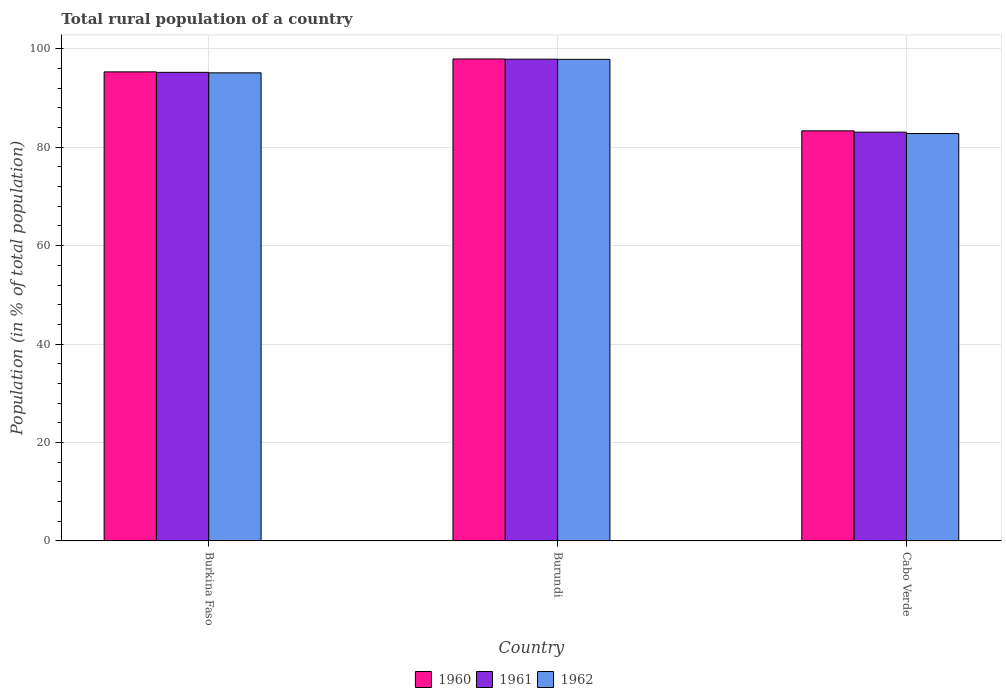How many bars are there on the 1st tick from the right?
Offer a very short reply. 3. What is the label of the 3rd group of bars from the left?
Offer a very short reply. Cabo Verde. In how many cases, is the number of bars for a given country not equal to the number of legend labels?
Provide a succinct answer. 0. What is the rural population in 1960 in Cabo Verde?
Your answer should be very brief. 83.32. Across all countries, what is the maximum rural population in 1960?
Your answer should be very brief. 97.92. Across all countries, what is the minimum rural population in 1962?
Give a very brief answer. 82.78. In which country was the rural population in 1961 maximum?
Your response must be concise. Burundi. In which country was the rural population in 1960 minimum?
Keep it short and to the point. Cabo Verde. What is the total rural population in 1962 in the graph?
Provide a succinct answer. 275.73. What is the difference between the rural population in 1960 in Burkina Faso and that in Burundi?
Your answer should be compact. -2.62. What is the difference between the rural population in 1960 in Cabo Verde and the rural population in 1961 in Burundi?
Give a very brief answer. -14.56. What is the average rural population in 1962 per country?
Offer a terse response. 91.91. What is the difference between the rural population of/in 1960 and rural population of/in 1961 in Cabo Verde?
Offer a terse response. 0.27. What is the ratio of the rural population in 1962 in Burundi to that in Cabo Verde?
Keep it short and to the point. 1.18. Is the rural population in 1960 in Burkina Faso less than that in Cabo Verde?
Offer a terse response. No. Is the difference between the rural population in 1960 in Burundi and Cabo Verde greater than the difference between the rural population in 1961 in Burundi and Cabo Verde?
Your response must be concise. No. What is the difference between the highest and the second highest rural population in 1962?
Your answer should be very brief. 15.07. What is the difference between the highest and the lowest rural population in 1962?
Make the answer very short. 15.07. In how many countries, is the rural population in 1962 greater than the average rural population in 1962 taken over all countries?
Make the answer very short. 2. What does the 1st bar from the right in Cabo Verde represents?
Offer a very short reply. 1962. Is it the case that in every country, the sum of the rural population in 1961 and rural population in 1960 is greater than the rural population in 1962?
Keep it short and to the point. Yes. How many bars are there?
Make the answer very short. 9. Are the values on the major ticks of Y-axis written in scientific E-notation?
Give a very brief answer. No. Does the graph contain grids?
Your response must be concise. Yes. Where does the legend appear in the graph?
Provide a short and direct response. Bottom center. How many legend labels are there?
Provide a succinct answer. 3. How are the legend labels stacked?
Your answer should be compact. Horizontal. What is the title of the graph?
Provide a short and direct response. Total rural population of a country. What is the label or title of the X-axis?
Give a very brief answer. Country. What is the label or title of the Y-axis?
Offer a very short reply. Population (in % of total population). What is the Population (in % of total population) of 1960 in Burkina Faso?
Your answer should be compact. 95.3. What is the Population (in % of total population) in 1961 in Burkina Faso?
Offer a terse response. 95.2. What is the Population (in % of total population) of 1962 in Burkina Faso?
Keep it short and to the point. 95.11. What is the Population (in % of total population) of 1960 in Burundi?
Your answer should be compact. 97.92. What is the Population (in % of total population) in 1961 in Burundi?
Your answer should be very brief. 97.89. What is the Population (in % of total population) of 1962 in Burundi?
Keep it short and to the point. 97.85. What is the Population (in % of total population) of 1960 in Cabo Verde?
Provide a succinct answer. 83.32. What is the Population (in % of total population) of 1961 in Cabo Verde?
Provide a short and direct response. 83.05. What is the Population (in % of total population) in 1962 in Cabo Verde?
Make the answer very short. 82.78. Across all countries, what is the maximum Population (in % of total population) in 1960?
Offer a terse response. 97.92. Across all countries, what is the maximum Population (in % of total population) in 1961?
Give a very brief answer. 97.89. Across all countries, what is the maximum Population (in % of total population) of 1962?
Make the answer very short. 97.85. Across all countries, what is the minimum Population (in % of total population) in 1960?
Your response must be concise. 83.32. Across all countries, what is the minimum Population (in % of total population) of 1961?
Provide a succinct answer. 83.05. Across all countries, what is the minimum Population (in % of total population) of 1962?
Your response must be concise. 82.78. What is the total Population (in % of total population) in 1960 in the graph?
Your response must be concise. 276.54. What is the total Population (in % of total population) of 1961 in the graph?
Provide a succinct answer. 276.14. What is the total Population (in % of total population) in 1962 in the graph?
Ensure brevity in your answer.  275.73. What is the difference between the Population (in % of total population) of 1960 in Burkina Faso and that in Burundi?
Your answer should be very brief. -2.62. What is the difference between the Population (in % of total population) of 1961 in Burkina Faso and that in Burundi?
Provide a short and direct response. -2.68. What is the difference between the Population (in % of total population) of 1962 in Burkina Faso and that in Burundi?
Ensure brevity in your answer.  -2.74. What is the difference between the Population (in % of total population) of 1960 in Burkina Faso and that in Cabo Verde?
Your answer should be very brief. 11.98. What is the difference between the Population (in % of total population) of 1961 in Burkina Faso and that in Cabo Verde?
Provide a succinct answer. 12.15. What is the difference between the Population (in % of total population) in 1962 in Burkina Faso and that in Cabo Verde?
Keep it short and to the point. 12.33. What is the difference between the Population (in % of total population) of 1960 in Burundi and that in Cabo Verde?
Make the answer very short. 14.6. What is the difference between the Population (in % of total population) in 1961 in Burundi and that in Cabo Verde?
Give a very brief answer. 14.83. What is the difference between the Population (in % of total population) in 1962 in Burundi and that in Cabo Verde?
Keep it short and to the point. 15.07. What is the difference between the Population (in % of total population) of 1960 in Burkina Faso and the Population (in % of total population) of 1961 in Burundi?
Your response must be concise. -2.58. What is the difference between the Population (in % of total population) in 1960 in Burkina Faso and the Population (in % of total population) in 1962 in Burundi?
Offer a terse response. -2.55. What is the difference between the Population (in % of total population) of 1961 in Burkina Faso and the Population (in % of total population) of 1962 in Burundi?
Provide a short and direct response. -2.64. What is the difference between the Population (in % of total population) in 1960 in Burkina Faso and the Population (in % of total population) in 1961 in Cabo Verde?
Keep it short and to the point. 12.25. What is the difference between the Population (in % of total population) of 1960 in Burkina Faso and the Population (in % of total population) of 1962 in Cabo Verde?
Ensure brevity in your answer.  12.52. What is the difference between the Population (in % of total population) in 1961 in Burkina Faso and the Population (in % of total population) in 1962 in Cabo Verde?
Provide a short and direct response. 12.43. What is the difference between the Population (in % of total population) in 1960 in Burundi and the Population (in % of total population) in 1961 in Cabo Verde?
Offer a terse response. 14.87. What is the difference between the Population (in % of total population) of 1960 in Burundi and the Population (in % of total population) of 1962 in Cabo Verde?
Offer a very short reply. 15.15. What is the difference between the Population (in % of total population) of 1961 in Burundi and the Population (in % of total population) of 1962 in Cabo Verde?
Make the answer very short. 15.11. What is the average Population (in % of total population) of 1960 per country?
Your answer should be compact. 92.18. What is the average Population (in % of total population) of 1961 per country?
Your answer should be compact. 92.05. What is the average Population (in % of total population) of 1962 per country?
Your response must be concise. 91.91. What is the difference between the Population (in % of total population) in 1960 and Population (in % of total population) in 1961 in Burkina Faso?
Provide a succinct answer. 0.1. What is the difference between the Population (in % of total population) in 1960 and Population (in % of total population) in 1962 in Burkina Faso?
Make the answer very short. 0.19. What is the difference between the Population (in % of total population) in 1961 and Population (in % of total population) in 1962 in Burkina Faso?
Offer a very short reply. 0.1. What is the difference between the Population (in % of total population) of 1960 and Population (in % of total population) of 1961 in Burundi?
Offer a very short reply. 0.04. What is the difference between the Population (in % of total population) of 1960 and Population (in % of total population) of 1962 in Burundi?
Your answer should be very brief. 0.08. What is the difference between the Population (in % of total population) in 1961 and Population (in % of total population) in 1962 in Burundi?
Give a very brief answer. 0.04. What is the difference between the Population (in % of total population) in 1960 and Population (in % of total population) in 1961 in Cabo Verde?
Provide a short and direct response. 0.27. What is the difference between the Population (in % of total population) of 1960 and Population (in % of total population) of 1962 in Cabo Verde?
Make the answer very short. 0.55. What is the difference between the Population (in % of total population) in 1961 and Population (in % of total population) in 1962 in Cabo Verde?
Offer a terse response. 0.28. What is the ratio of the Population (in % of total population) of 1960 in Burkina Faso to that in Burundi?
Provide a short and direct response. 0.97. What is the ratio of the Population (in % of total population) of 1961 in Burkina Faso to that in Burundi?
Make the answer very short. 0.97. What is the ratio of the Population (in % of total population) of 1960 in Burkina Faso to that in Cabo Verde?
Your answer should be very brief. 1.14. What is the ratio of the Population (in % of total population) in 1961 in Burkina Faso to that in Cabo Verde?
Provide a succinct answer. 1.15. What is the ratio of the Population (in % of total population) in 1962 in Burkina Faso to that in Cabo Verde?
Your answer should be compact. 1.15. What is the ratio of the Population (in % of total population) in 1960 in Burundi to that in Cabo Verde?
Your response must be concise. 1.18. What is the ratio of the Population (in % of total population) in 1961 in Burundi to that in Cabo Verde?
Ensure brevity in your answer.  1.18. What is the ratio of the Population (in % of total population) in 1962 in Burundi to that in Cabo Verde?
Your answer should be compact. 1.18. What is the difference between the highest and the second highest Population (in % of total population) of 1960?
Make the answer very short. 2.62. What is the difference between the highest and the second highest Population (in % of total population) in 1961?
Ensure brevity in your answer.  2.68. What is the difference between the highest and the second highest Population (in % of total population) in 1962?
Provide a short and direct response. 2.74. What is the difference between the highest and the lowest Population (in % of total population) in 1960?
Keep it short and to the point. 14.6. What is the difference between the highest and the lowest Population (in % of total population) of 1961?
Ensure brevity in your answer.  14.83. What is the difference between the highest and the lowest Population (in % of total population) in 1962?
Provide a succinct answer. 15.07. 